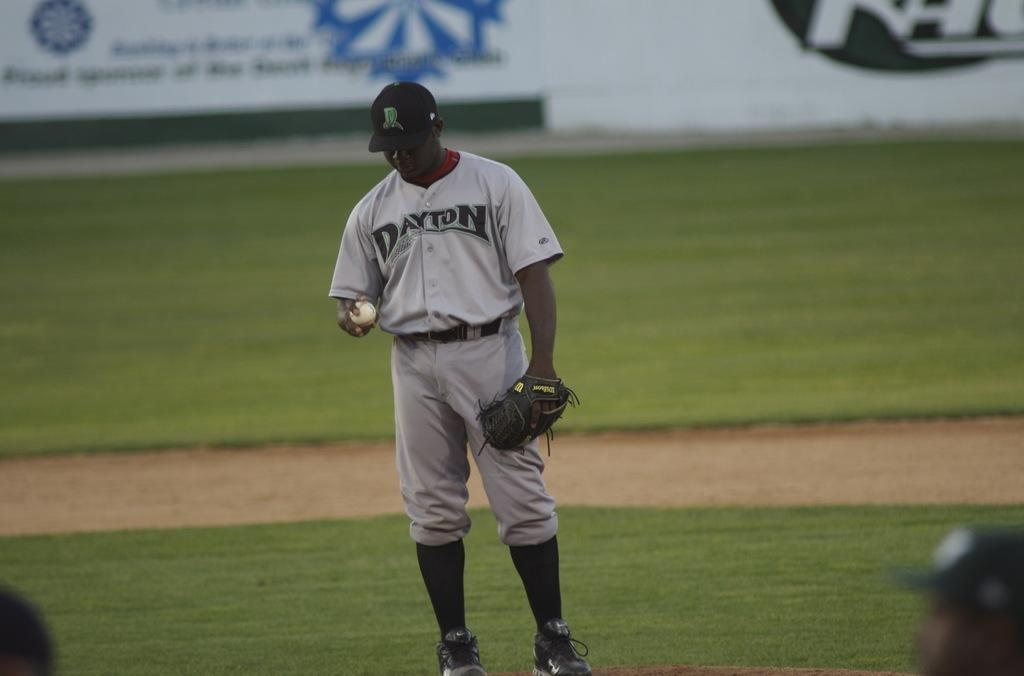<image>
Present a compact description of the photo's key features. a Dayton baseball player looking at the baseball in his hand. 